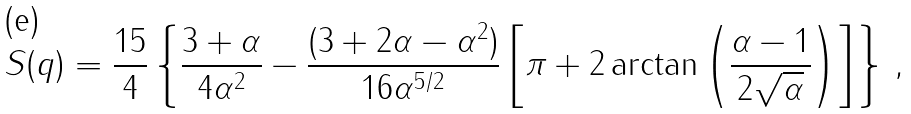<formula> <loc_0><loc_0><loc_500><loc_500>S ( q ) = \frac { 1 5 } { 4 } \left \{ \frac { 3 + \alpha } { 4 \alpha ^ { 2 } } - \frac { ( 3 + 2 \alpha - \alpha ^ { 2 } ) } { 1 6 \alpha ^ { 5 / 2 } } \left [ \pi + 2 \arctan { \left ( \frac { \alpha - 1 } { 2 \sqrt { \alpha } } \right ) } \right ] \right \} \, ,</formula> 